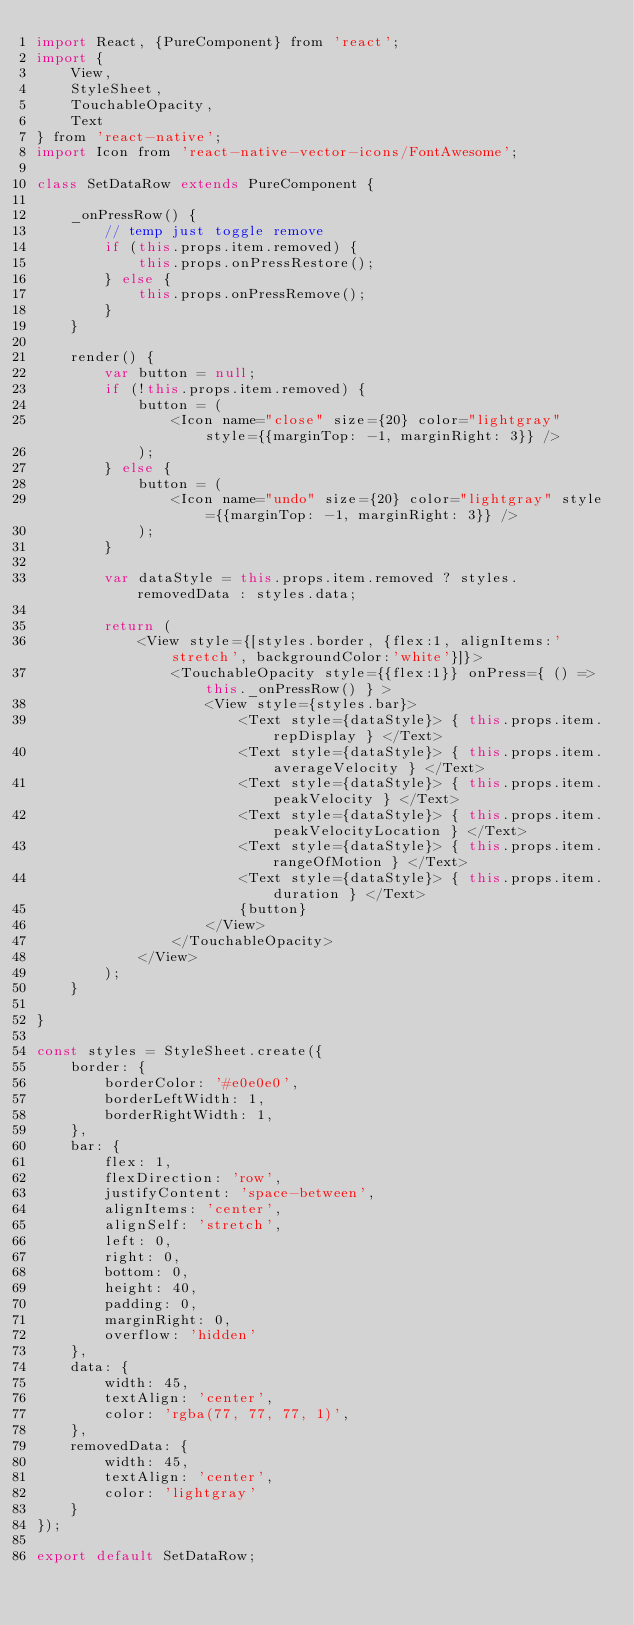<code> <loc_0><loc_0><loc_500><loc_500><_JavaScript_>import React, {PureComponent} from 'react';
import {
    View,
    StyleSheet,
    TouchableOpacity,
    Text
} from 'react-native';
import Icon from 'react-native-vector-icons/FontAwesome';

class SetDataRow extends PureComponent {

    _onPressRow() {
        // temp just toggle remove
        if (this.props.item.removed) {
            this.props.onPressRestore();
        } else {
            this.props.onPressRemove();
        }
    }

    render() {
        var button = null;
        if (!this.props.item.removed) {
            button = (
                <Icon name="close" size={20} color="lightgray" style={{marginTop: -1, marginRight: 3}} />
            );
        } else {
            button = (
                <Icon name="undo" size={20} color="lightgray" style={{marginTop: -1, marginRight: 3}} />
            );
        }

        var dataStyle = this.props.item.removed ? styles.removedData : styles.data;
        
        return (
            <View style={[styles.border, {flex:1, alignItems:'stretch', backgroundColor:'white'}]}>
                <TouchableOpacity style={{flex:1}} onPress={ () => this._onPressRow() } >
                    <View style={styles.bar}>
                        <Text style={dataStyle}> { this.props.item.repDisplay } </Text>
                        <Text style={dataStyle}> { this.props.item.averageVelocity } </Text>
                        <Text style={dataStyle}> { this.props.item.peakVelocity } </Text>
                        <Text style={dataStyle}> { this.props.item.peakVelocityLocation } </Text>
                        <Text style={dataStyle}> { this.props.item.rangeOfMotion } </Text>
                        <Text style={dataStyle}> { this.props.item.duration } </Text>
                        {button}
                    </View>
                </TouchableOpacity>
            </View>
        );
    }

}

const styles = StyleSheet.create({
    border: {
        borderColor: '#e0e0e0',
        borderLeftWidth: 1,
        borderRightWidth: 1,
    },
    bar: {
        flex: 1,
        flexDirection: 'row',
        justifyContent: 'space-between',
        alignItems: 'center',
        alignSelf: 'stretch',
        left: 0,
        right: 0,
        bottom: 0,
        height: 40,
        padding: 0,
        marginRight: 0,
        overflow: 'hidden'
    },
    data: {
        width: 45,
        textAlign: 'center',
        color: 'rgba(77, 77, 77, 1)',
    },
    removedData: {
        width: 45,
        textAlign: 'center',
        color: 'lightgray'
    }
});

export default SetDataRow;
</code> 